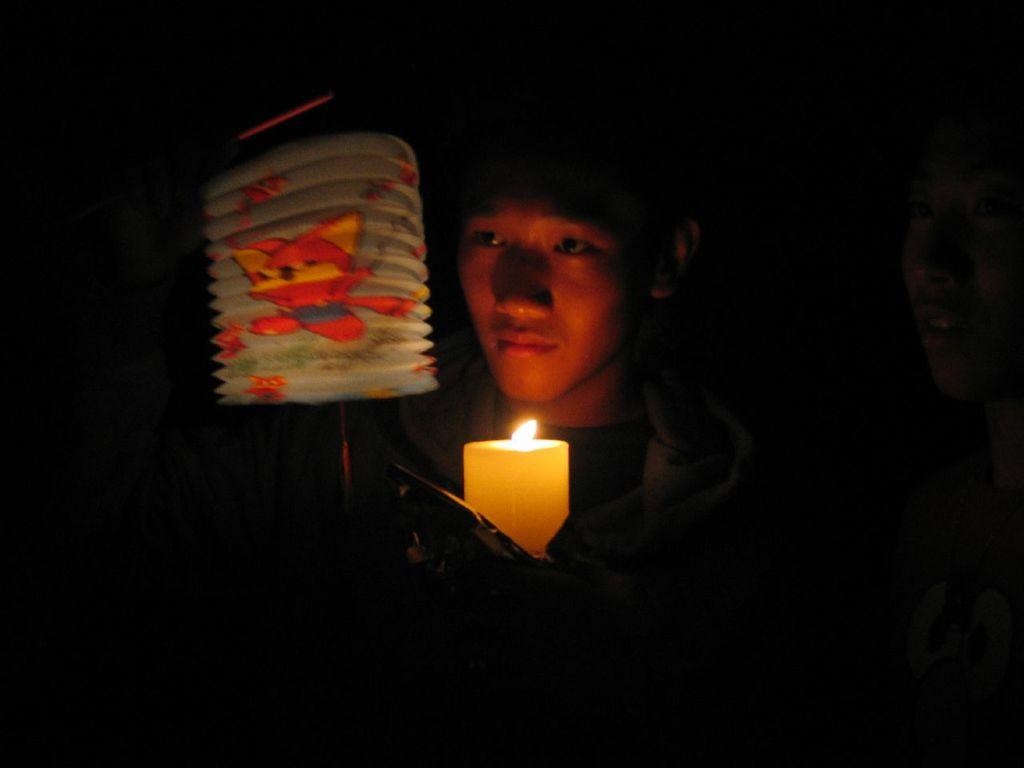What is the main subject of the image? The main subject of the image is a kid. What is the kid doing in the image? The kid is standing in the image. What objects is the kid holding in his hands? The kid is holding a lit candle and a box in his hands. Can you see any thumbs in the image? There is no mention of thumbs in the image, so we cannot determine if any are present. What type of pickle is the kid holding in the image? There is no pickle present in the image; the kid is holding a lit candle and a box. 